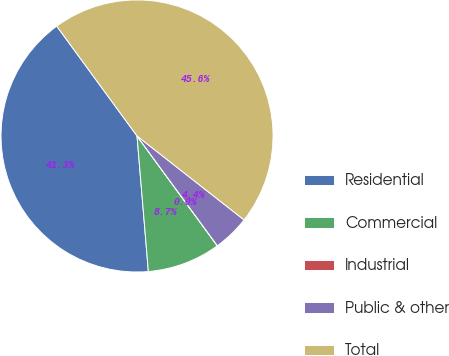Convert chart. <chart><loc_0><loc_0><loc_500><loc_500><pie_chart><fcel>Residential<fcel>Commercial<fcel>Industrial<fcel>Public & other<fcel>Total<nl><fcel>41.28%<fcel>8.72%<fcel>0.01%<fcel>4.36%<fcel>45.63%<nl></chart> 